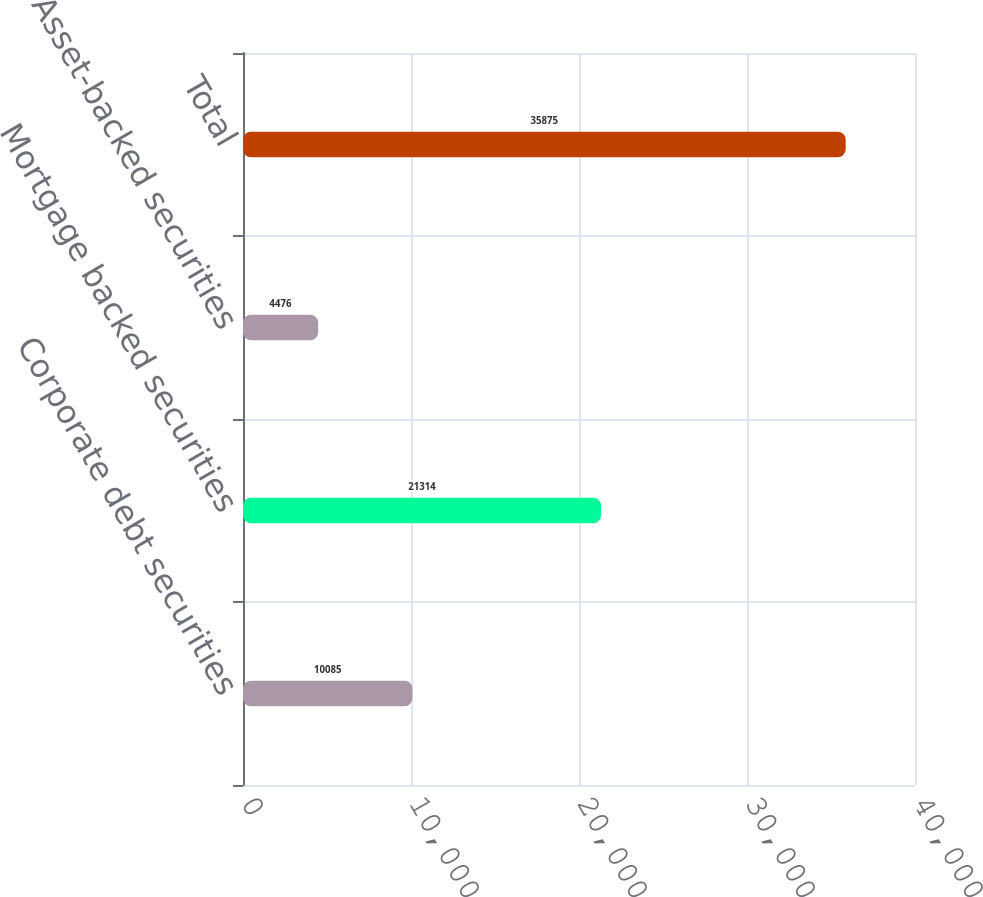<chart> <loc_0><loc_0><loc_500><loc_500><bar_chart><fcel>Corporate debt securities<fcel>Mortgage backed securities<fcel>Asset-backed securities<fcel>Total<nl><fcel>10085<fcel>21314<fcel>4476<fcel>35875<nl></chart> 